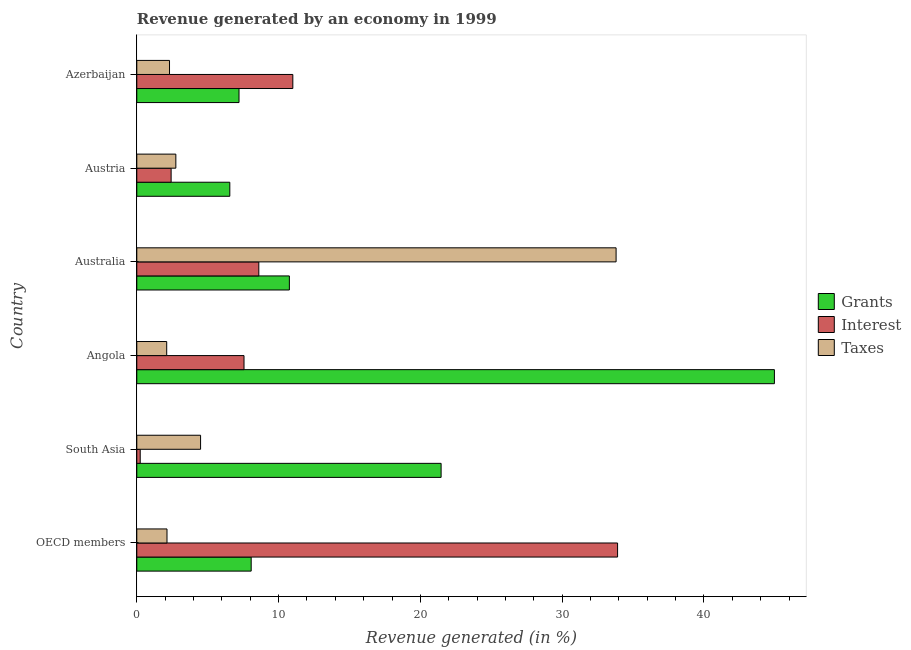How many different coloured bars are there?
Make the answer very short. 3. Are the number of bars per tick equal to the number of legend labels?
Offer a very short reply. Yes. Are the number of bars on each tick of the Y-axis equal?
Keep it short and to the point. Yes. How many bars are there on the 2nd tick from the top?
Offer a terse response. 3. How many bars are there on the 5th tick from the bottom?
Provide a short and direct response. 3. What is the label of the 6th group of bars from the top?
Provide a succinct answer. OECD members. What is the percentage of revenue generated by grants in Austria?
Make the answer very short. 6.56. Across all countries, what is the maximum percentage of revenue generated by interest?
Provide a short and direct response. 33.91. Across all countries, what is the minimum percentage of revenue generated by grants?
Make the answer very short. 6.56. In which country was the percentage of revenue generated by grants maximum?
Provide a short and direct response. Angola. In which country was the percentage of revenue generated by interest minimum?
Provide a succinct answer. South Asia. What is the total percentage of revenue generated by grants in the graph?
Offer a very short reply. 99.02. What is the difference between the percentage of revenue generated by grants in Angola and that in OECD members?
Provide a succinct answer. 36.9. What is the difference between the percentage of revenue generated by grants in Angola and the percentage of revenue generated by interest in Australia?
Provide a short and direct response. 36.36. What is the average percentage of revenue generated by interest per country?
Offer a very short reply. 10.62. What is the difference between the percentage of revenue generated by grants and percentage of revenue generated by interest in OECD members?
Provide a short and direct response. -25.84. In how many countries, is the percentage of revenue generated by interest greater than 38 %?
Offer a terse response. 0. What is the ratio of the percentage of revenue generated by taxes in Austria to that in Azerbaijan?
Give a very brief answer. 1.19. Is the difference between the percentage of revenue generated by taxes in Australia and Austria greater than the difference between the percentage of revenue generated by interest in Australia and Austria?
Your answer should be compact. Yes. What is the difference between the highest and the second highest percentage of revenue generated by taxes?
Keep it short and to the point. 29.3. What is the difference between the highest and the lowest percentage of revenue generated by grants?
Offer a very short reply. 38.41. In how many countries, is the percentage of revenue generated by interest greater than the average percentage of revenue generated by interest taken over all countries?
Keep it short and to the point. 2. What does the 1st bar from the top in Australia represents?
Ensure brevity in your answer.  Taxes. What does the 3rd bar from the bottom in Angola represents?
Offer a terse response. Taxes. How many bars are there?
Offer a terse response. 18. Are the values on the major ticks of X-axis written in scientific E-notation?
Make the answer very short. No. Does the graph contain grids?
Provide a short and direct response. No. Where does the legend appear in the graph?
Your answer should be very brief. Center right. How many legend labels are there?
Ensure brevity in your answer.  3. What is the title of the graph?
Make the answer very short. Revenue generated by an economy in 1999. Does "Gaseous fuel" appear as one of the legend labels in the graph?
Give a very brief answer. No. What is the label or title of the X-axis?
Your answer should be compact. Revenue generated (in %). What is the label or title of the Y-axis?
Your answer should be very brief. Country. What is the Revenue generated (in %) of Grants in OECD members?
Provide a short and direct response. 8.07. What is the Revenue generated (in %) of Interest in OECD members?
Make the answer very short. 33.91. What is the Revenue generated (in %) in Taxes in OECD members?
Your answer should be compact. 2.13. What is the Revenue generated (in %) of Grants in South Asia?
Your response must be concise. 21.46. What is the Revenue generated (in %) in Interest in South Asia?
Offer a very short reply. 0.24. What is the Revenue generated (in %) of Taxes in South Asia?
Offer a terse response. 4.5. What is the Revenue generated (in %) of Grants in Angola?
Your answer should be compact. 44.97. What is the Revenue generated (in %) in Interest in Angola?
Your answer should be compact. 7.56. What is the Revenue generated (in %) of Taxes in Angola?
Offer a terse response. 2.11. What is the Revenue generated (in %) of Grants in Australia?
Offer a terse response. 10.76. What is the Revenue generated (in %) in Interest in Australia?
Offer a very short reply. 8.6. What is the Revenue generated (in %) of Taxes in Australia?
Make the answer very short. 33.8. What is the Revenue generated (in %) of Grants in Austria?
Make the answer very short. 6.56. What is the Revenue generated (in %) of Interest in Austria?
Your response must be concise. 2.42. What is the Revenue generated (in %) of Taxes in Austria?
Your response must be concise. 2.75. What is the Revenue generated (in %) of Grants in Azerbaijan?
Offer a terse response. 7.21. What is the Revenue generated (in %) of Interest in Azerbaijan?
Offer a terse response. 11. What is the Revenue generated (in %) of Taxes in Azerbaijan?
Make the answer very short. 2.31. Across all countries, what is the maximum Revenue generated (in %) in Grants?
Give a very brief answer. 44.97. Across all countries, what is the maximum Revenue generated (in %) in Interest?
Provide a succinct answer. 33.91. Across all countries, what is the maximum Revenue generated (in %) of Taxes?
Offer a very short reply. 33.8. Across all countries, what is the minimum Revenue generated (in %) in Grants?
Your response must be concise. 6.56. Across all countries, what is the minimum Revenue generated (in %) of Interest?
Offer a terse response. 0.24. Across all countries, what is the minimum Revenue generated (in %) in Taxes?
Make the answer very short. 2.11. What is the total Revenue generated (in %) in Grants in the graph?
Your answer should be very brief. 99.02. What is the total Revenue generated (in %) in Interest in the graph?
Your answer should be compact. 63.74. What is the total Revenue generated (in %) of Taxes in the graph?
Offer a terse response. 47.6. What is the difference between the Revenue generated (in %) of Grants in OECD members and that in South Asia?
Your answer should be very brief. -13.39. What is the difference between the Revenue generated (in %) in Interest in OECD members and that in South Asia?
Your response must be concise. 33.66. What is the difference between the Revenue generated (in %) in Taxes in OECD members and that in South Asia?
Give a very brief answer. -2.37. What is the difference between the Revenue generated (in %) of Grants in OECD members and that in Angola?
Make the answer very short. -36.9. What is the difference between the Revenue generated (in %) in Interest in OECD members and that in Angola?
Ensure brevity in your answer.  26.34. What is the difference between the Revenue generated (in %) of Taxes in OECD members and that in Angola?
Your answer should be compact. 0.02. What is the difference between the Revenue generated (in %) in Grants in OECD members and that in Australia?
Your response must be concise. -2.69. What is the difference between the Revenue generated (in %) of Interest in OECD members and that in Australia?
Your response must be concise. 25.3. What is the difference between the Revenue generated (in %) of Taxes in OECD members and that in Australia?
Offer a very short reply. -31.67. What is the difference between the Revenue generated (in %) in Grants in OECD members and that in Austria?
Keep it short and to the point. 1.51. What is the difference between the Revenue generated (in %) of Interest in OECD members and that in Austria?
Offer a very short reply. 31.49. What is the difference between the Revenue generated (in %) of Taxes in OECD members and that in Austria?
Offer a very short reply. -0.62. What is the difference between the Revenue generated (in %) in Grants in OECD members and that in Azerbaijan?
Ensure brevity in your answer.  0.86. What is the difference between the Revenue generated (in %) of Interest in OECD members and that in Azerbaijan?
Ensure brevity in your answer.  22.9. What is the difference between the Revenue generated (in %) in Taxes in OECD members and that in Azerbaijan?
Provide a short and direct response. -0.18. What is the difference between the Revenue generated (in %) of Grants in South Asia and that in Angola?
Offer a terse response. -23.5. What is the difference between the Revenue generated (in %) of Interest in South Asia and that in Angola?
Give a very brief answer. -7.32. What is the difference between the Revenue generated (in %) in Taxes in South Asia and that in Angola?
Make the answer very short. 2.39. What is the difference between the Revenue generated (in %) in Grants in South Asia and that in Australia?
Your answer should be very brief. 10.7. What is the difference between the Revenue generated (in %) in Interest in South Asia and that in Australia?
Provide a short and direct response. -8.36. What is the difference between the Revenue generated (in %) in Taxes in South Asia and that in Australia?
Offer a terse response. -29.3. What is the difference between the Revenue generated (in %) in Grants in South Asia and that in Austria?
Your answer should be compact. 14.9. What is the difference between the Revenue generated (in %) of Interest in South Asia and that in Austria?
Your answer should be very brief. -2.18. What is the difference between the Revenue generated (in %) in Taxes in South Asia and that in Austria?
Offer a very short reply. 1.74. What is the difference between the Revenue generated (in %) of Grants in South Asia and that in Azerbaijan?
Keep it short and to the point. 14.25. What is the difference between the Revenue generated (in %) in Interest in South Asia and that in Azerbaijan?
Your answer should be very brief. -10.76. What is the difference between the Revenue generated (in %) of Taxes in South Asia and that in Azerbaijan?
Provide a short and direct response. 2.19. What is the difference between the Revenue generated (in %) in Grants in Angola and that in Australia?
Provide a succinct answer. 34.2. What is the difference between the Revenue generated (in %) of Interest in Angola and that in Australia?
Your answer should be compact. -1.04. What is the difference between the Revenue generated (in %) in Taxes in Angola and that in Australia?
Ensure brevity in your answer.  -31.69. What is the difference between the Revenue generated (in %) in Grants in Angola and that in Austria?
Provide a short and direct response. 38.41. What is the difference between the Revenue generated (in %) in Interest in Angola and that in Austria?
Offer a terse response. 5.14. What is the difference between the Revenue generated (in %) of Taxes in Angola and that in Austria?
Make the answer very short. -0.64. What is the difference between the Revenue generated (in %) of Grants in Angola and that in Azerbaijan?
Make the answer very short. 37.76. What is the difference between the Revenue generated (in %) of Interest in Angola and that in Azerbaijan?
Ensure brevity in your answer.  -3.44. What is the difference between the Revenue generated (in %) in Taxes in Angola and that in Azerbaijan?
Your answer should be compact. -0.2. What is the difference between the Revenue generated (in %) in Grants in Australia and that in Austria?
Offer a terse response. 4.2. What is the difference between the Revenue generated (in %) of Interest in Australia and that in Austria?
Your response must be concise. 6.18. What is the difference between the Revenue generated (in %) of Taxes in Australia and that in Austria?
Your response must be concise. 31.05. What is the difference between the Revenue generated (in %) of Grants in Australia and that in Azerbaijan?
Your answer should be compact. 3.55. What is the difference between the Revenue generated (in %) of Interest in Australia and that in Azerbaijan?
Provide a short and direct response. -2.4. What is the difference between the Revenue generated (in %) of Taxes in Australia and that in Azerbaijan?
Your answer should be very brief. 31.49. What is the difference between the Revenue generated (in %) in Grants in Austria and that in Azerbaijan?
Your answer should be compact. -0.65. What is the difference between the Revenue generated (in %) in Interest in Austria and that in Azerbaijan?
Your response must be concise. -8.58. What is the difference between the Revenue generated (in %) in Taxes in Austria and that in Azerbaijan?
Your response must be concise. 0.45. What is the difference between the Revenue generated (in %) in Grants in OECD members and the Revenue generated (in %) in Interest in South Asia?
Provide a succinct answer. 7.83. What is the difference between the Revenue generated (in %) of Grants in OECD members and the Revenue generated (in %) of Taxes in South Asia?
Ensure brevity in your answer.  3.57. What is the difference between the Revenue generated (in %) of Interest in OECD members and the Revenue generated (in %) of Taxes in South Asia?
Offer a very short reply. 29.41. What is the difference between the Revenue generated (in %) of Grants in OECD members and the Revenue generated (in %) of Interest in Angola?
Keep it short and to the point. 0.51. What is the difference between the Revenue generated (in %) in Grants in OECD members and the Revenue generated (in %) in Taxes in Angola?
Your answer should be compact. 5.96. What is the difference between the Revenue generated (in %) of Interest in OECD members and the Revenue generated (in %) of Taxes in Angola?
Offer a terse response. 31.8. What is the difference between the Revenue generated (in %) in Grants in OECD members and the Revenue generated (in %) in Interest in Australia?
Offer a terse response. -0.54. What is the difference between the Revenue generated (in %) in Grants in OECD members and the Revenue generated (in %) in Taxes in Australia?
Offer a terse response. -25.73. What is the difference between the Revenue generated (in %) of Interest in OECD members and the Revenue generated (in %) of Taxes in Australia?
Your answer should be compact. 0.1. What is the difference between the Revenue generated (in %) in Grants in OECD members and the Revenue generated (in %) in Interest in Austria?
Make the answer very short. 5.65. What is the difference between the Revenue generated (in %) in Grants in OECD members and the Revenue generated (in %) in Taxes in Austria?
Your answer should be very brief. 5.31. What is the difference between the Revenue generated (in %) in Interest in OECD members and the Revenue generated (in %) in Taxes in Austria?
Keep it short and to the point. 31.15. What is the difference between the Revenue generated (in %) of Grants in OECD members and the Revenue generated (in %) of Interest in Azerbaijan?
Offer a terse response. -2.94. What is the difference between the Revenue generated (in %) of Grants in OECD members and the Revenue generated (in %) of Taxes in Azerbaijan?
Offer a very short reply. 5.76. What is the difference between the Revenue generated (in %) of Interest in OECD members and the Revenue generated (in %) of Taxes in Azerbaijan?
Offer a very short reply. 31.6. What is the difference between the Revenue generated (in %) in Grants in South Asia and the Revenue generated (in %) in Interest in Angola?
Make the answer very short. 13.9. What is the difference between the Revenue generated (in %) of Grants in South Asia and the Revenue generated (in %) of Taxes in Angola?
Your response must be concise. 19.35. What is the difference between the Revenue generated (in %) in Interest in South Asia and the Revenue generated (in %) in Taxes in Angola?
Make the answer very short. -1.87. What is the difference between the Revenue generated (in %) in Grants in South Asia and the Revenue generated (in %) in Interest in Australia?
Offer a very short reply. 12.86. What is the difference between the Revenue generated (in %) in Grants in South Asia and the Revenue generated (in %) in Taxes in Australia?
Your response must be concise. -12.34. What is the difference between the Revenue generated (in %) in Interest in South Asia and the Revenue generated (in %) in Taxes in Australia?
Your answer should be compact. -33.56. What is the difference between the Revenue generated (in %) in Grants in South Asia and the Revenue generated (in %) in Interest in Austria?
Offer a very short reply. 19.04. What is the difference between the Revenue generated (in %) of Grants in South Asia and the Revenue generated (in %) of Taxes in Austria?
Offer a terse response. 18.71. What is the difference between the Revenue generated (in %) in Interest in South Asia and the Revenue generated (in %) in Taxes in Austria?
Offer a terse response. -2.51. What is the difference between the Revenue generated (in %) in Grants in South Asia and the Revenue generated (in %) in Interest in Azerbaijan?
Provide a succinct answer. 10.46. What is the difference between the Revenue generated (in %) in Grants in South Asia and the Revenue generated (in %) in Taxes in Azerbaijan?
Your response must be concise. 19.15. What is the difference between the Revenue generated (in %) in Interest in South Asia and the Revenue generated (in %) in Taxes in Azerbaijan?
Your response must be concise. -2.07. What is the difference between the Revenue generated (in %) in Grants in Angola and the Revenue generated (in %) in Interest in Australia?
Provide a short and direct response. 36.36. What is the difference between the Revenue generated (in %) in Grants in Angola and the Revenue generated (in %) in Taxes in Australia?
Your answer should be compact. 11.16. What is the difference between the Revenue generated (in %) of Interest in Angola and the Revenue generated (in %) of Taxes in Australia?
Your answer should be compact. -26.24. What is the difference between the Revenue generated (in %) of Grants in Angola and the Revenue generated (in %) of Interest in Austria?
Provide a short and direct response. 42.54. What is the difference between the Revenue generated (in %) of Grants in Angola and the Revenue generated (in %) of Taxes in Austria?
Make the answer very short. 42.21. What is the difference between the Revenue generated (in %) in Interest in Angola and the Revenue generated (in %) in Taxes in Austria?
Make the answer very short. 4.81. What is the difference between the Revenue generated (in %) in Grants in Angola and the Revenue generated (in %) in Interest in Azerbaijan?
Your answer should be very brief. 33.96. What is the difference between the Revenue generated (in %) in Grants in Angola and the Revenue generated (in %) in Taxes in Azerbaijan?
Offer a terse response. 42.66. What is the difference between the Revenue generated (in %) in Interest in Angola and the Revenue generated (in %) in Taxes in Azerbaijan?
Your response must be concise. 5.25. What is the difference between the Revenue generated (in %) in Grants in Australia and the Revenue generated (in %) in Interest in Austria?
Provide a succinct answer. 8.34. What is the difference between the Revenue generated (in %) of Grants in Australia and the Revenue generated (in %) of Taxes in Austria?
Make the answer very short. 8.01. What is the difference between the Revenue generated (in %) in Interest in Australia and the Revenue generated (in %) in Taxes in Austria?
Your response must be concise. 5.85. What is the difference between the Revenue generated (in %) of Grants in Australia and the Revenue generated (in %) of Interest in Azerbaijan?
Make the answer very short. -0.24. What is the difference between the Revenue generated (in %) of Grants in Australia and the Revenue generated (in %) of Taxes in Azerbaijan?
Your answer should be compact. 8.45. What is the difference between the Revenue generated (in %) in Interest in Australia and the Revenue generated (in %) in Taxes in Azerbaijan?
Provide a succinct answer. 6.3. What is the difference between the Revenue generated (in %) of Grants in Austria and the Revenue generated (in %) of Interest in Azerbaijan?
Your response must be concise. -4.44. What is the difference between the Revenue generated (in %) in Grants in Austria and the Revenue generated (in %) in Taxes in Azerbaijan?
Ensure brevity in your answer.  4.25. What is the difference between the Revenue generated (in %) of Interest in Austria and the Revenue generated (in %) of Taxes in Azerbaijan?
Your answer should be compact. 0.11. What is the average Revenue generated (in %) in Grants per country?
Your answer should be compact. 16.5. What is the average Revenue generated (in %) of Interest per country?
Your answer should be very brief. 10.62. What is the average Revenue generated (in %) in Taxes per country?
Provide a short and direct response. 7.93. What is the difference between the Revenue generated (in %) of Grants and Revenue generated (in %) of Interest in OECD members?
Offer a very short reply. -25.84. What is the difference between the Revenue generated (in %) in Grants and Revenue generated (in %) in Taxes in OECD members?
Keep it short and to the point. 5.94. What is the difference between the Revenue generated (in %) in Interest and Revenue generated (in %) in Taxes in OECD members?
Ensure brevity in your answer.  31.78. What is the difference between the Revenue generated (in %) in Grants and Revenue generated (in %) in Interest in South Asia?
Your response must be concise. 21.22. What is the difference between the Revenue generated (in %) in Grants and Revenue generated (in %) in Taxes in South Asia?
Make the answer very short. 16.96. What is the difference between the Revenue generated (in %) in Interest and Revenue generated (in %) in Taxes in South Asia?
Your response must be concise. -4.26. What is the difference between the Revenue generated (in %) in Grants and Revenue generated (in %) in Interest in Angola?
Provide a short and direct response. 37.4. What is the difference between the Revenue generated (in %) of Grants and Revenue generated (in %) of Taxes in Angola?
Provide a short and direct response. 42.86. What is the difference between the Revenue generated (in %) of Interest and Revenue generated (in %) of Taxes in Angola?
Provide a succinct answer. 5.45. What is the difference between the Revenue generated (in %) in Grants and Revenue generated (in %) in Interest in Australia?
Your answer should be very brief. 2.16. What is the difference between the Revenue generated (in %) of Grants and Revenue generated (in %) of Taxes in Australia?
Provide a succinct answer. -23.04. What is the difference between the Revenue generated (in %) of Interest and Revenue generated (in %) of Taxes in Australia?
Your response must be concise. -25.2. What is the difference between the Revenue generated (in %) of Grants and Revenue generated (in %) of Interest in Austria?
Your answer should be compact. 4.14. What is the difference between the Revenue generated (in %) in Grants and Revenue generated (in %) in Taxes in Austria?
Provide a short and direct response. 3.81. What is the difference between the Revenue generated (in %) in Grants and Revenue generated (in %) in Interest in Azerbaijan?
Give a very brief answer. -3.8. What is the difference between the Revenue generated (in %) of Grants and Revenue generated (in %) of Taxes in Azerbaijan?
Your answer should be compact. 4.9. What is the difference between the Revenue generated (in %) in Interest and Revenue generated (in %) in Taxes in Azerbaijan?
Your answer should be compact. 8.7. What is the ratio of the Revenue generated (in %) in Grants in OECD members to that in South Asia?
Your answer should be very brief. 0.38. What is the ratio of the Revenue generated (in %) of Interest in OECD members to that in South Asia?
Your answer should be very brief. 140.52. What is the ratio of the Revenue generated (in %) of Taxes in OECD members to that in South Asia?
Provide a short and direct response. 0.47. What is the ratio of the Revenue generated (in %) of Grants in OECD members to that in Angola?
Provide a short and direct response. 0.18. What is the ratio of the Revenue generated (in %) of Interest in OECD members to that in Angola?
Provide a succinct answer. 4.48. What is the ratio of the Revenue generated (in %) in Taxes in OECD members to that in Angola?
Your answer should be very brief. 1.01. What is the ratio of the Revenue generated (in %) of Grants in OECD members to that in Australia?
Offer a very short reply. 0.75. What is the ratio of the Revenue generated (in %) of Interest in OECD members to that in Australia?
Make the answer very short. 3.94. What is the ratio of the Revenue generated (in %) of Taxes in OECD members to that in Australia?
Ensure brevity in your answer.  0.06. What is the ratio of the Revenue generated (in %) in Grants in OECD members to that in Austria?
Ensure brevity in your answer.  1.23. What is the ratio of the Revenue generated (in %) in Interest in OECD members to that in Austria?
Your answer should be very brief. 14. What is the ratio of the Revenue generated (in %) of Taxes in OECD members to that in Austria?
Make the answer very short. 0.77. What is the ratio of the Revenue generated (in %) in Grants in OECD members to that in Azerbaijan?
Provide a succinct answer. 1.12. What is the ratio of the Revenue generated (in %) of Interest in OECD members to that in Azerbaijan?
Your answer should be very brief. 3.08. What is the ratio of the Revenue generated (in %) of Taxes in OECD members to that in Azerbaijan?
Give a very brief answer. 0.92. What is the ratio of the Revenue generated (in %) in Grants in South Asia to that in Angola?
Your answer should be compact. 0.48. What is the ratio of the Revenue generated (in %) in Interest in South Asia to that in Angola?
Make the answer very short. 0.03. What is the ratio of the Revenue generated (in %) in Taxes in South Asia to that in Angola?
Offer a terse response. 2.13. What is the ratio of the Revenue generated (in %) of Grants in South Asia to that in Australia?
Your answer should be very brief. 1.99. What is the ratio of the Revenue generated (in %) of Interest in South Asia to that in Australia?
Make the answer very short. 0.03. What is the ratio of the Revenue generated (in %) of Taxes in South Asia to that in Australia?
Your response must be concise. 0.13. What is the ratio of the Revenue generated (in %) in Grants in South Asia to that in Austria?
Your response must be concise. 3.27. What is the ratio of the Revenue generated (in %) in Interest in South Asia to that in Austria?
Offer a terse response. 0.1. What is the ratio of the Revenue generated (in %) in Taxes in South Asia to that in Austria?
Your answer should be very brief. 1.63. What is the ratio of the Revenue generated (in %) of Grants in South Asia to that in Azerbaijan?
Keep it short and to the point. 2.98. What is the ratio of the Revenue generated (in %) in Interest in South Asia to that in Azerbaijan?
Offer a very short reply. 0.02. What is the ratio of the Revenue generated (in %) in Taxes in South Asia to that in Azerbaijan?
Your response must be concise. 1.95. What is the ratio of the Revenue generated (in %) of Grants in Angola to that in Australia?
Give a very brief answer. 4.18. What is the ratio of the Revenue generated (in %) in Interest in Angola to that in Australia?
Your answer should be compact. 0.88. What is the ratio of the Revenue generated (in %) in Taxes in Angola to that in Australia?
Give a very brief answer. 0.06. What is the ratio of the Revenue generated (in %) in Grants in Angola to that in Austria?
Your response must be concise. 6.85. What is the ratio of the Revenue generated (in %) of Interest in Angola to that in Austria?
Offer a terse response. 3.12. What is the ratio of the Revenue generated (in %) in Taxes in Angola to that in Austria?
Provide a succinct answer. 0.77. What is the ratio of the Revenue generated (in %) of Grants in Angola to that in Azerbaijan?
Make the answer very short. 6.24. What is the ratio of the Revenue generated (in %) in Interest in Angola to that in Azerbaijan?
Your answer should be very brief. 0.69. What is the ratio of the Revenue generated (in %) of Taxes in Angola to that in Azerbaijan?
Your response must be concise. 0.91. What is the ratio of the Revenue generated (in %) of Grants in Australia to that in Austria?
Your answer should be very brief. 1.64. What is the ratio of the Revenue generated (in %) in Interest in Australia to that in Austria?
Provide a short and direct response. 3.55. What is the ratio of the Revenue generated (in %) of Taxes in Australia to that in Austria?
Your answer should be very brief. 12.27. What is the ratio of the Revenue generated (in %) of Grants in Australia to that in Azerbaijan?
Ensure brevity in your answer.  1.49. What is the ratio of the Revenue generated (in %) in Interest in Australia to that in Azerbaijan?
Make the answer very short. 0.78. What is the ratio of the Revenue generated (in %) in Taxes in Australia to that in Azerbaijan?
Provide a succinct answer. 14.65. What is the ratio of the Revenue generated (in %) of Grants in Austria to that in Azerbaijan?
Your answer should be very brief. 0.91. What is the ratio of the Revenue generated (in %) of Interest in Austria to that in Azerbaijan?
Offer a terse response. 0.22. What is the ratio of the Revenue generated (in %) in Taxes in Austria to that in Azerbaijan?
Offer a terse response. 1.19. What is the difference between the highest and the second highest Revenue generated (in %) of Grants?
Offer a very short reply. 23.5. What is the difference between the highest and the second highest Revenue generated (in %) in Interest?
Offer a very short reply. 22.9. What is the difference between the highest and the second highest Revenue generated (in %) in Taxes?
Give a very brief answer. 29.3. What is the difference between the highest and the lowest Revenue generated (in %) of Grants?
Give a very brief answer. 38.41. What is the difference between the highest and the lowest Revenue generated (in %) in Interest?
Provide a succinct answer. 33.66. What is the difference between the highest and the lowest Revenue generated (in %) of Taxes?
Keep it short and to the point. 31.69. 